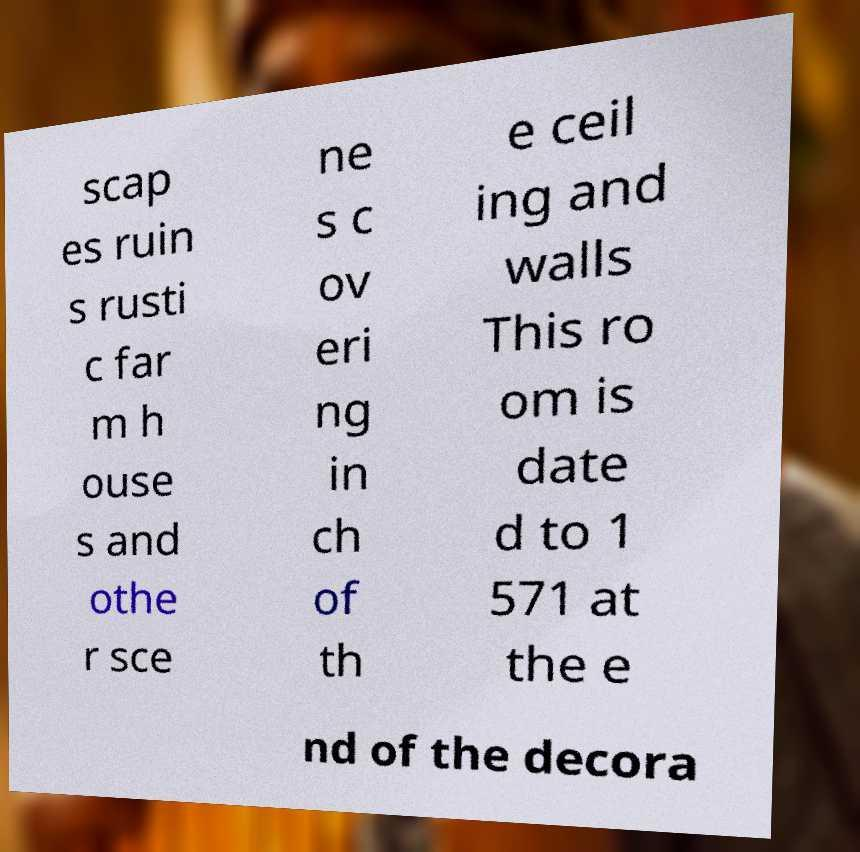What messages or text are displayed in this image? I need them in a readable, typed format. scap es ruin s rusti c far m h ouse s and othe r sce ne s c ov eri ng in ch of th e ceil ing and walls This ro om is date d to 1 571 at the e nd of the decora 